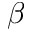<formula> <loc_0><loc_0><loc_500><loc_500>\beta</formula> 